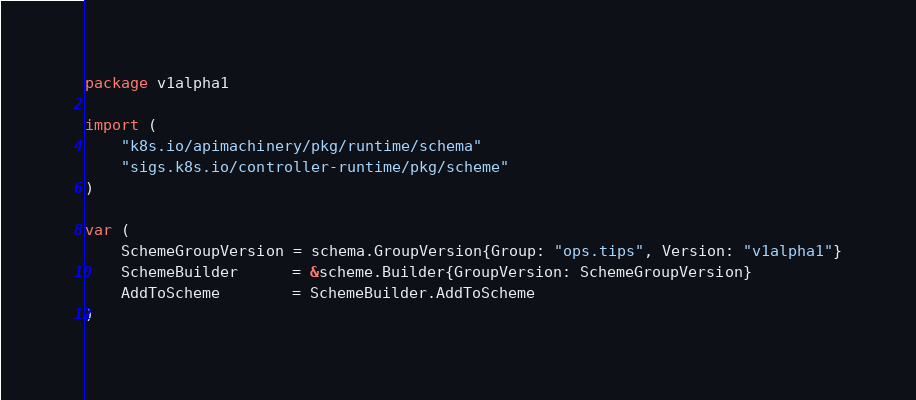Convert code to text. <code><loc_0><loc_0><loc_500><loc_500><_Go_>package v1alpha1

import (
	"k8s.io/apimachinery/pkg/runtime/schema"
	"sigs.k8s.io/controller-runtime/pkg/scheme"
)

var (
	SchemeGroupVersion = schema.GroupVersion{Group: "ops.tips", Version: "v1alpha1"}
	SchemeBuilder      = &scheme.Builder{GroupVersion: SchemeGroupVersion}
	AddToScheme        = SchemeBuilder.AddToScheme
)
</code> 